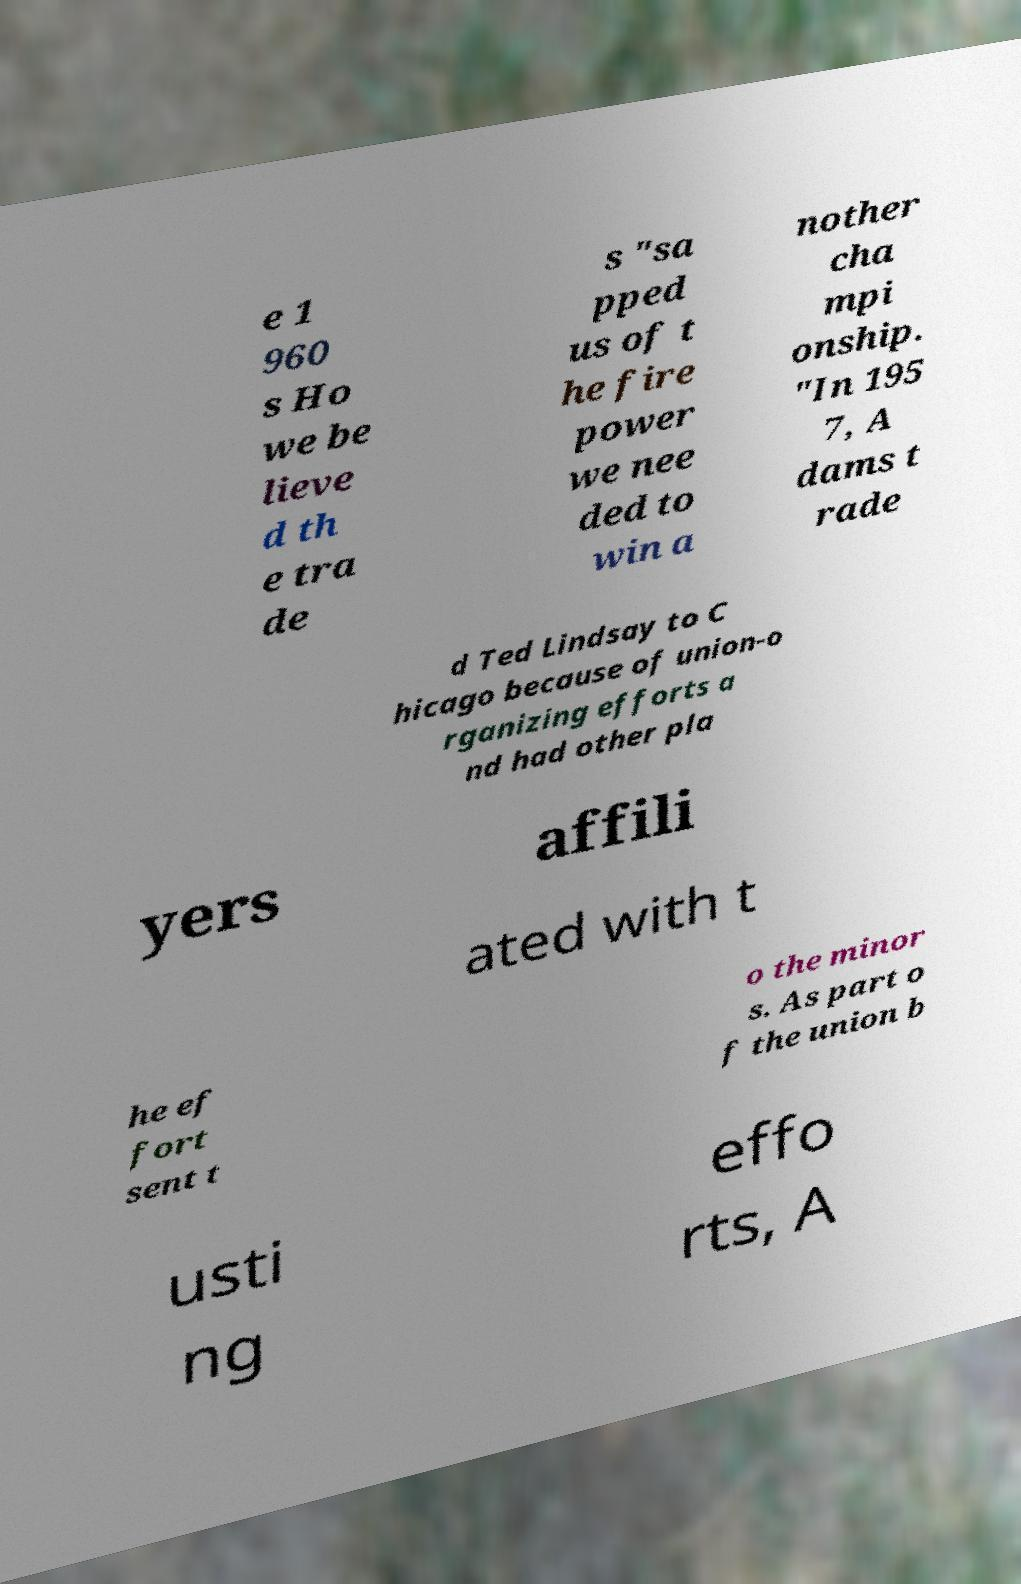There's text embedded in this image that I need extracted. Can you transcribe it verbatim? e 1 960 s Ho we be lieve d th e tra de s "sa pped us of t he fire power we nee ded to win a nother cha mpi onship. "In 195 7, A dams t rade d Ted Lindsay to C hicago because of union-o rganizing efforts a nd had other pla yers affili ated with t he ef fort sent t o the minor s. As part o f the union b usti ng effo rts, A 